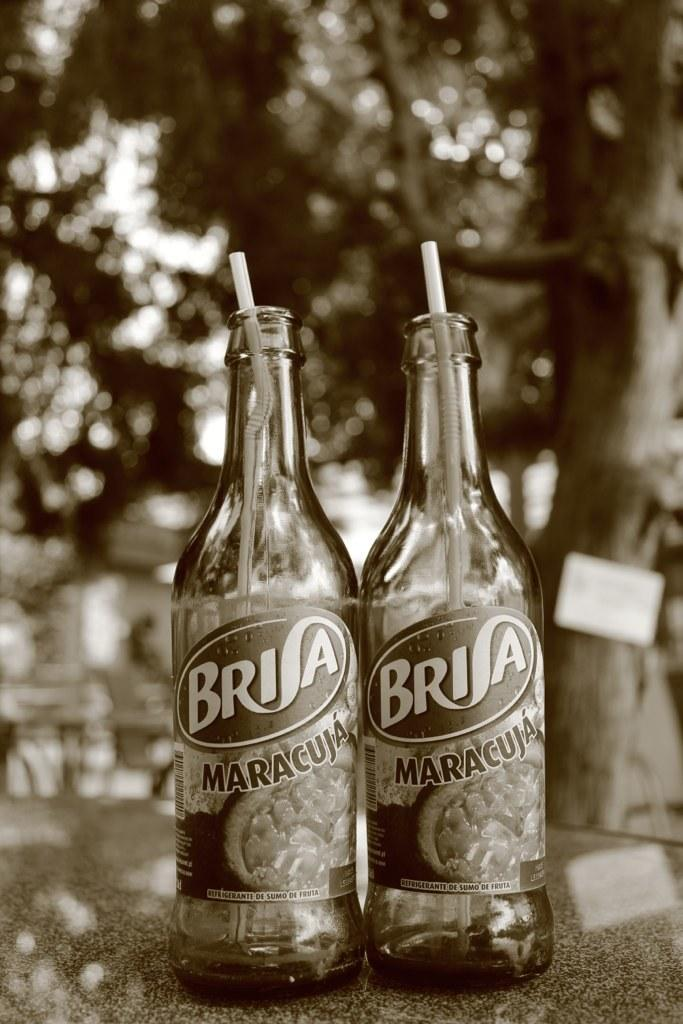<image>
Describe the image concisely. Two bottles of Brisa Maracuja are next to each other. 